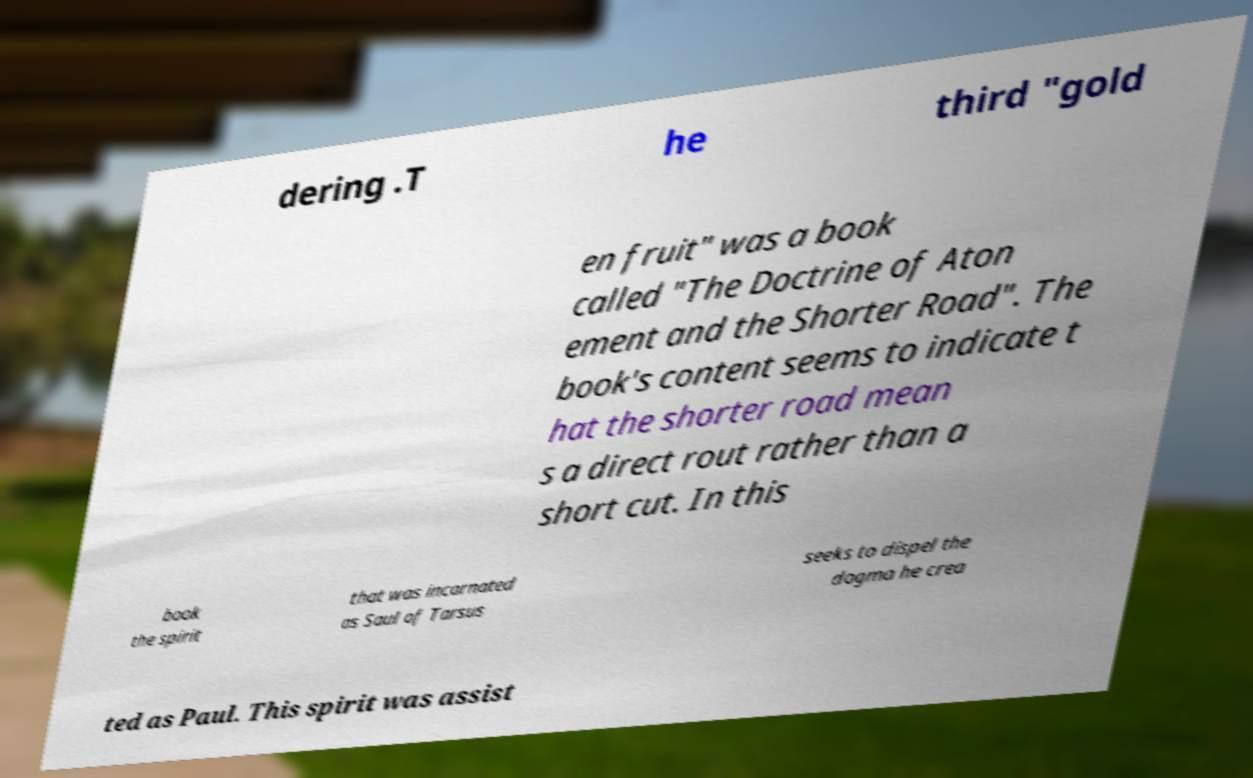For documentation purposes, I need the text within this image transcribed. Could you provide that? dering .T he third "gold en fruit" was a book called "The Doctrine of Aton ement and the Shorter Road". The book's content seems to indicate t hat the shorter road mean s a direct rout rather than a short cut. In this book the spirit that was incarnated as Saul of Tarsus seeks to dispel the dogma he crea ted as Paul. This spirit was assist 